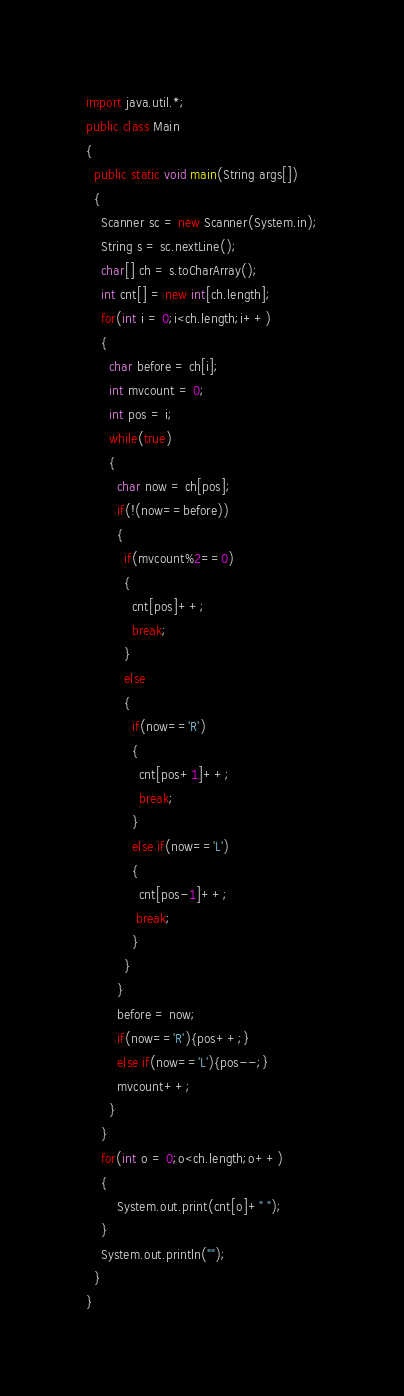Convert code to text. <code><loc_0><loc_0><loc_500><loc_500><_Java_>import java.util.*;
public class Main
{
  public static void main(String args[])
  {
    Scanner sc = new Scanner(System.in);
    String s = sc.nextLine();
    char[] ch = s.toCharArray();
    int cnt[] = new int[ch.length];
    for(int i = 0;i<ch.length;i++)
    {
      char before = ch[i];
      int mvcount = 0;
      int pos = i;
      while(true)
      {
        char now = ch[pos];
        if(!(now==before))
        {
          if(mvcount%2==0)
          {
            cnt[pos]++;
            break;
          }
          else
          {
            if(now=='R')
            {
              cnt[pos+1]++;
              break;
            }
            else if(now=='L')
            {
              cnt[pos-1]++;
             break; 
            }
          }
        }
        before = now;
        if(now=='R'){pos++;}
        else if(now=='L'){pos--;}
        mvcount++;
      }
    }
    for(int o = 0;o<ch.length;o++)
  	{
    	System.out.print(cnt[o]+" ");
  	}
  	System.out.println("");
  }
}</code> 